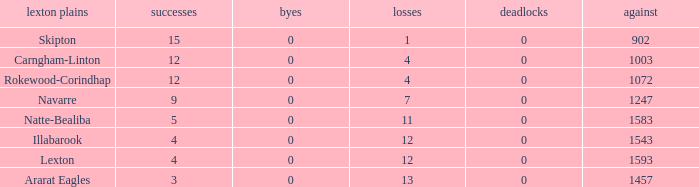What is the most wins with 0 byes? None. 